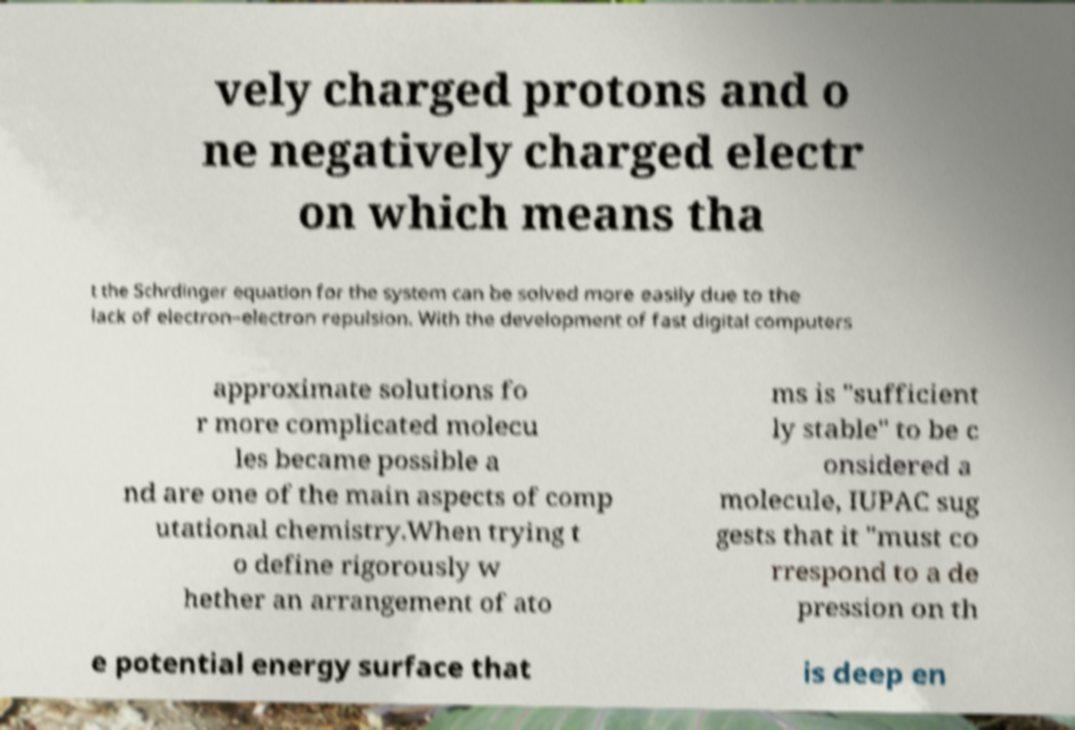What messages or text are displayed in this image? I need them in a readable, typed format. vely charged protons and o ne negatively charged electr on which means tha t the Schrdinger equation for the system can be solved more easily due to the lack of electron–electron repulsion. With the development of fast digital computers approximate solutions fo r more complicated molecu les became possible a nd are one of the main aspects of comp utational chemistry.When trying t o define rigorously w hether an arrangement of ato ms is "sufficient ly stable" to be c onsidered a molecule, IUPAC sug gests that it "must co rrespond to a de pression on th e potential energy surface that is deep en 